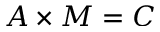Convert formula to latex. <formula><loc_0><loc_0><loc_500><loc_500>A \times M = C</formula> 